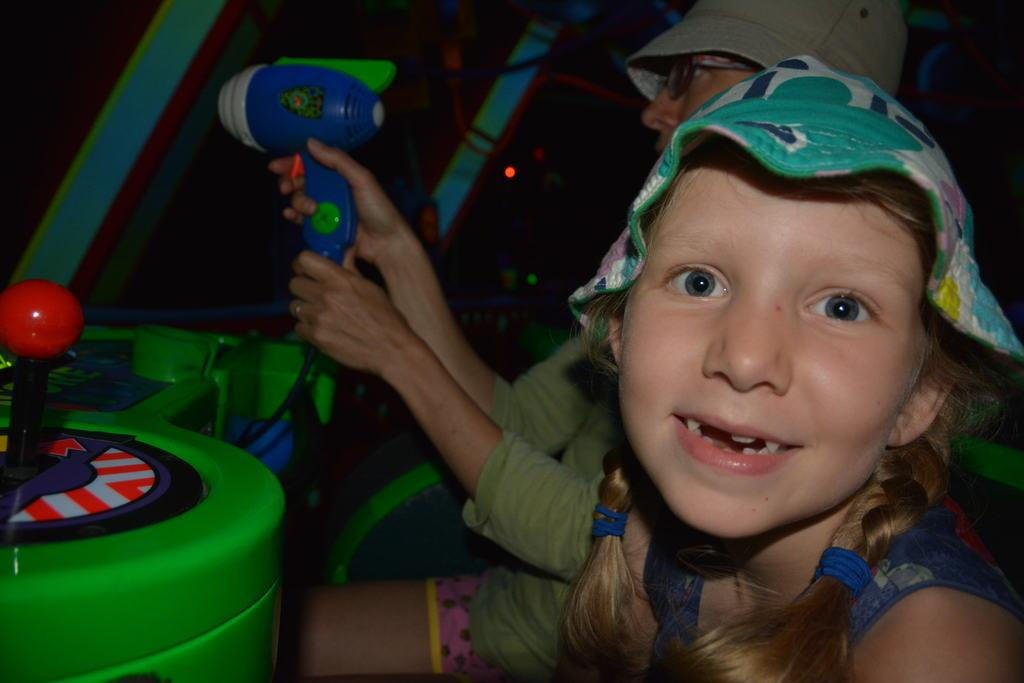How many people are in the image? There are two persons in the image. What are the persons wearing on their heads? Both persons are wearing caps. Can you describe what one of the persons is holding? One person is holding something, but we cannot determine what it is from the image. What part of an object can be seen in the image? There is a handle visible in the image. What type of invention is being demonstrated by the persons in the image? There is no invention being demonstrated in the image; it only shows two persons wearing caps and one holding something. Can you tell me how many light bulbs are visible in the image? There are no light bulbs present in the image. 